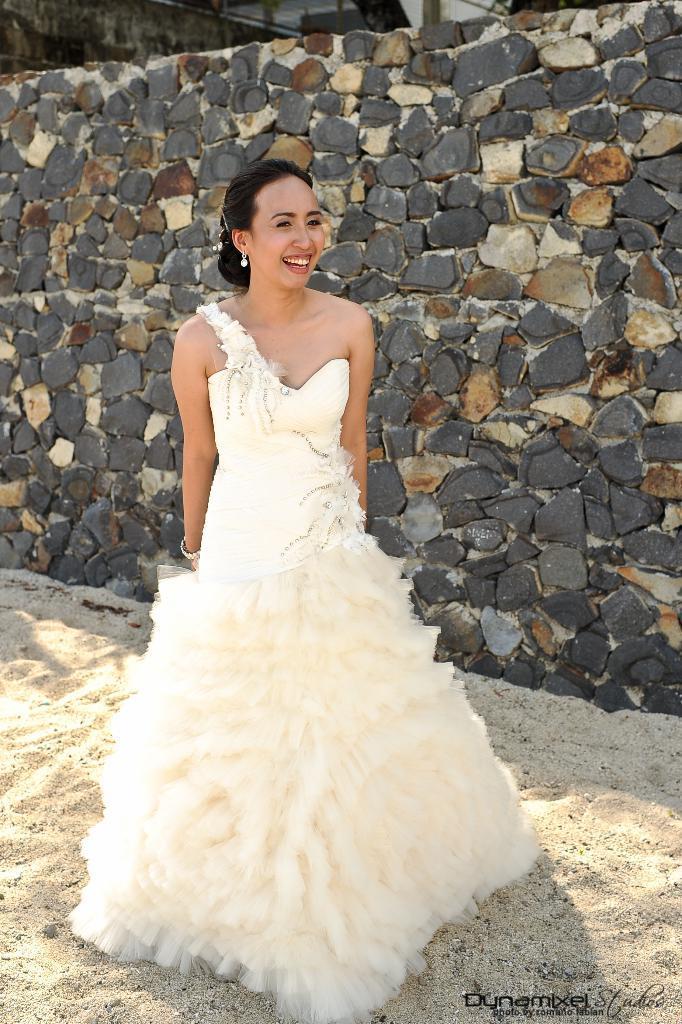Could you give a brief overview of what you see in this image? In this image, we can see a woman standing on the sand surface, she is wearing a white dress. In the background, we can see the stone wall. 